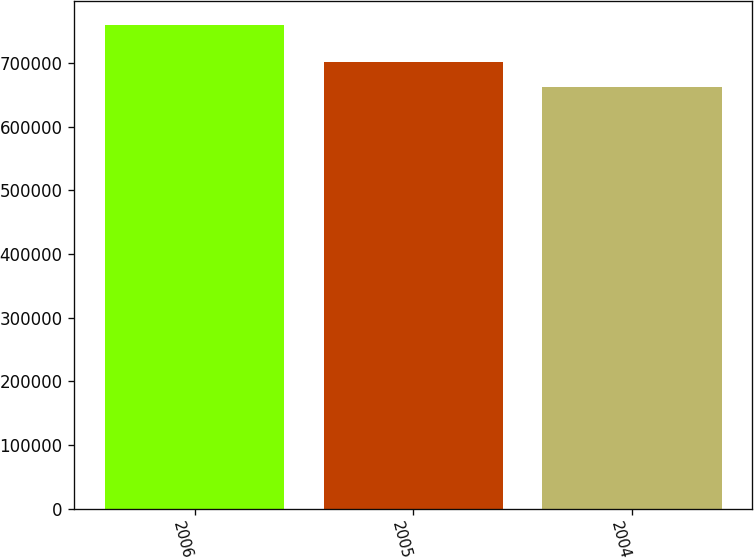Convert chart to OTSL. <chart><loc_0><loc_0><loc_500><loc_500><bar_chart><fcel>2006<fcel>2005<fcel>2004<nl><fcel>759524<fcel>702271<fcel>663054<nl></chart> 